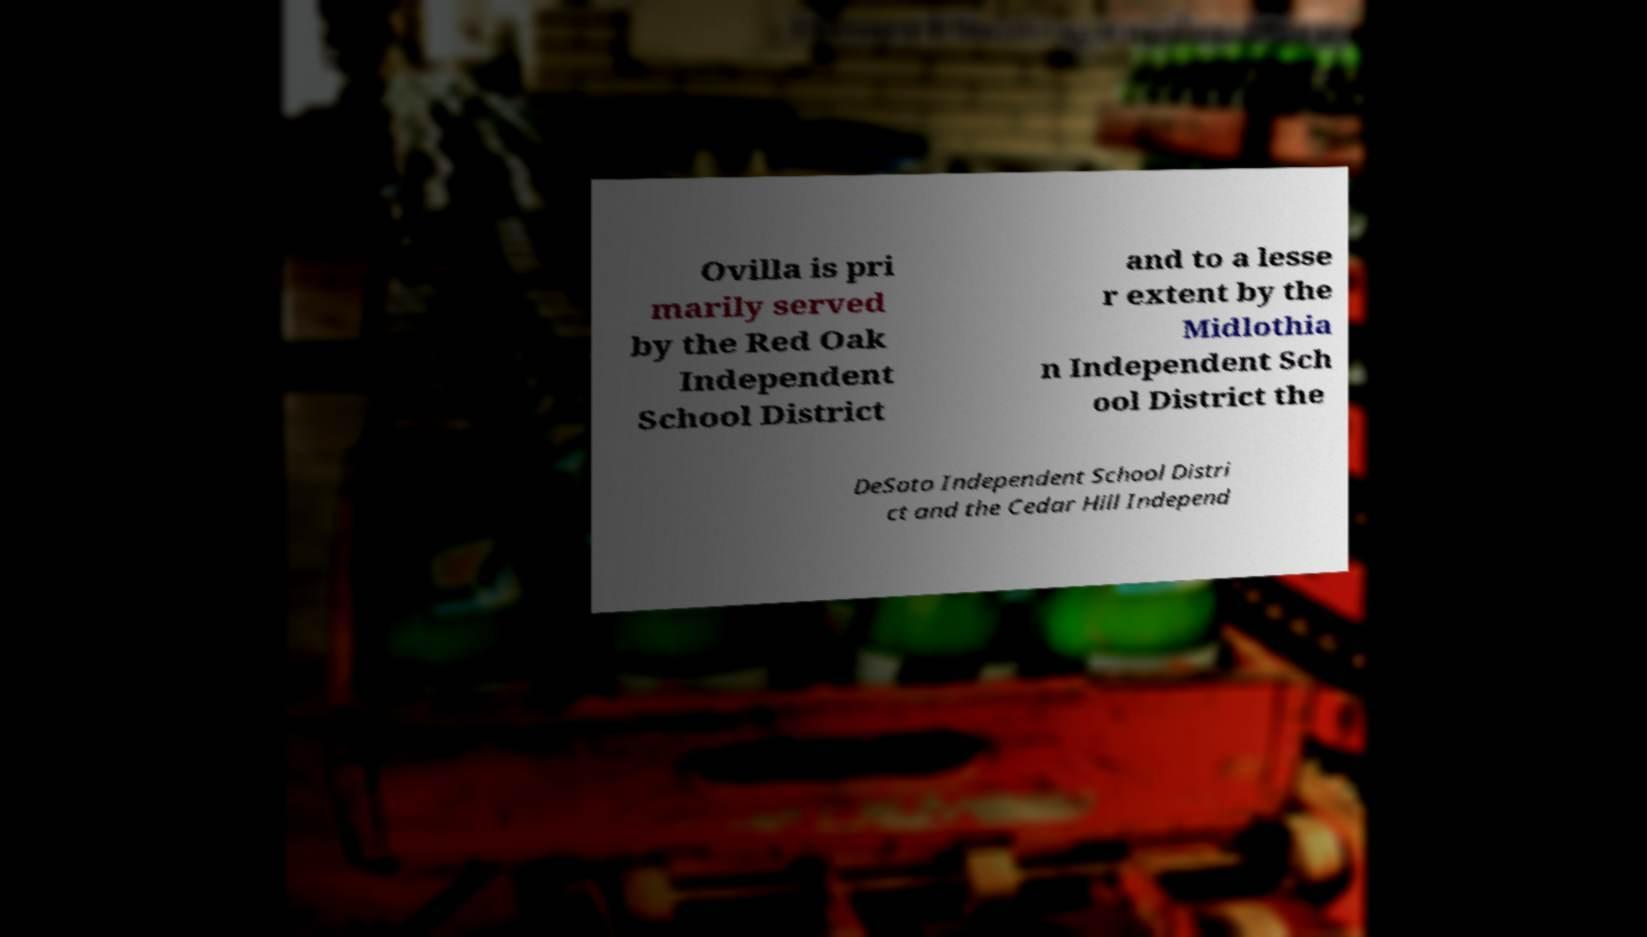Could you assist in decoding the text presented in this image and type it out clearly? Ovilla is pri marily served by the Red Oak Independent School District and to a lesse r extent by the Midlothia n Independent Sch ool District the DeSoto Independent School Distri ct and the Cedar Hill Independ 